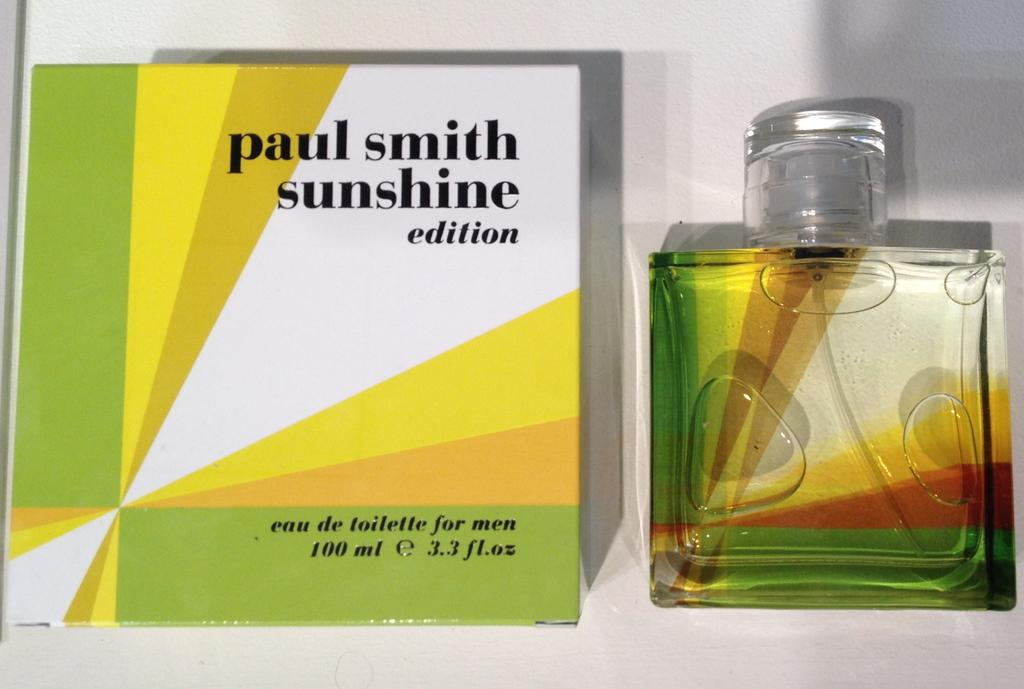<image>
Describe the image concisely. a box with the name paul smith on it 